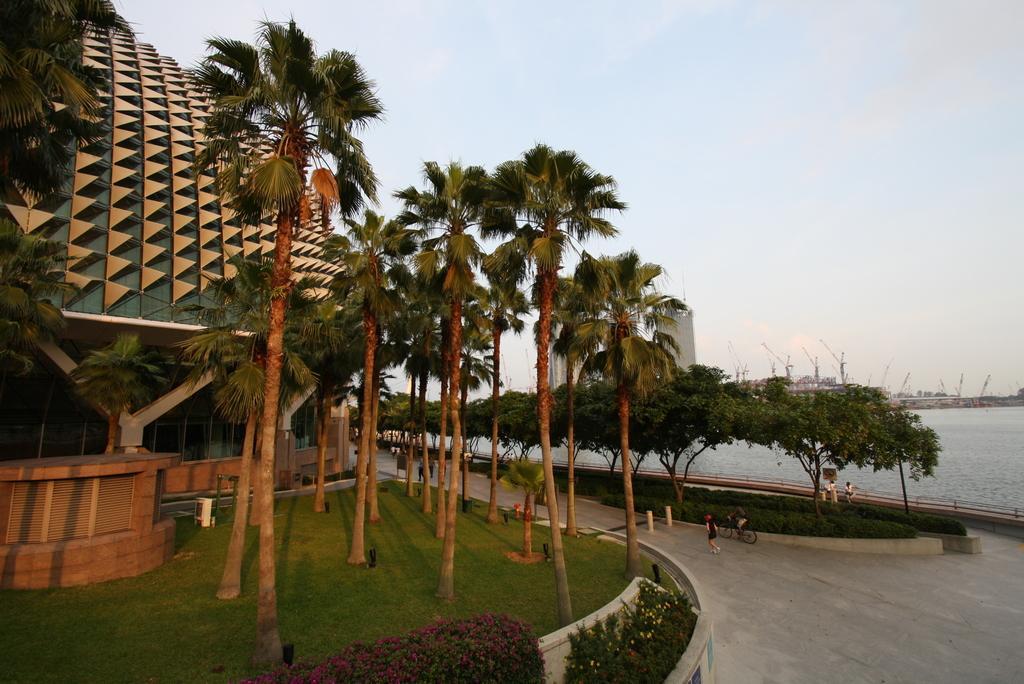Could you give a brief overview of what you see in this image? On the left we can see trees,plants with flowers,plants,grass,a building and some other objects. In the background we can see a person riding bicycle on the road,few persons,trees,grass,water,poles,buildings and clouds in the sky. 